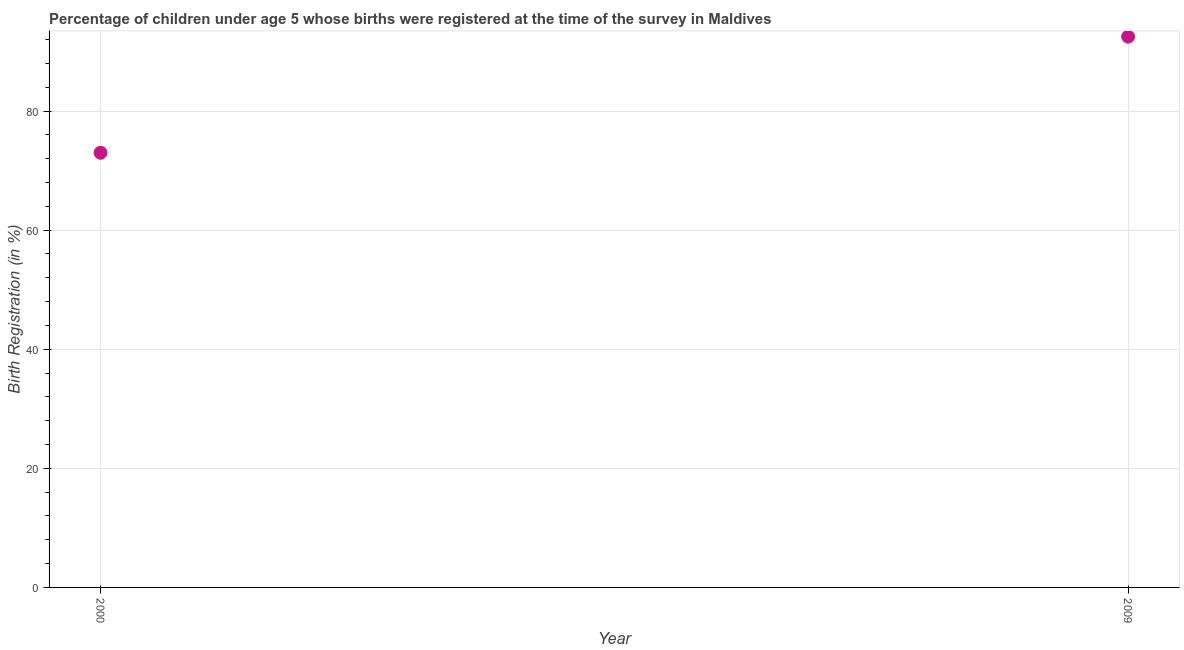What is the birth registration in 2000?
Keep it short and to the point. 73. Across all years, what is the maximum birth registration?
Your answer should be very brief. 92.5. Across all years, what is the minimum birth registration?
Provide a succinct answer. 73. What is the sum of the birth registration?
Offer a very short reply. 165.5. What is the difference between the birth registration in 2000 and 2009?
Your response must be concise. -19.5. What is the average birth registration per year?
Your response must be concise. 82.75. What is the median birth registration?
Make the answer very short. 82.75. What is the ratio of the birth registration in 2000 to that in 2009?
Your answer should be compact. 0.79. How many dotlines are there?
Your answer should be very brief. 1. What is the difference between two consecutive major ticks on the Y-axis?
Offer a very short reply. 20. Does the graph contain any zero values?
Ensure brevity in your answer.  No. What is the title of the graph?
Ensure brevity in your answer.  Percentage of children under age 5 whose births were registered at the time of the survey in Maldives. What is the label or title of the Y-axis?
Ensure brevity in your answer.  Birth Registration (in %). What is the Birth Registration (in %) in 2009?
Make the answer very short. 92.5. What is the difference between the Birth Registration (in %) in 2000 and 2009?
Your answer should be very brief. -19.5. What is the ratio of the Birth Registration (in %) in 2000 to that in 2009?
Make the answer very short. 0.79. 